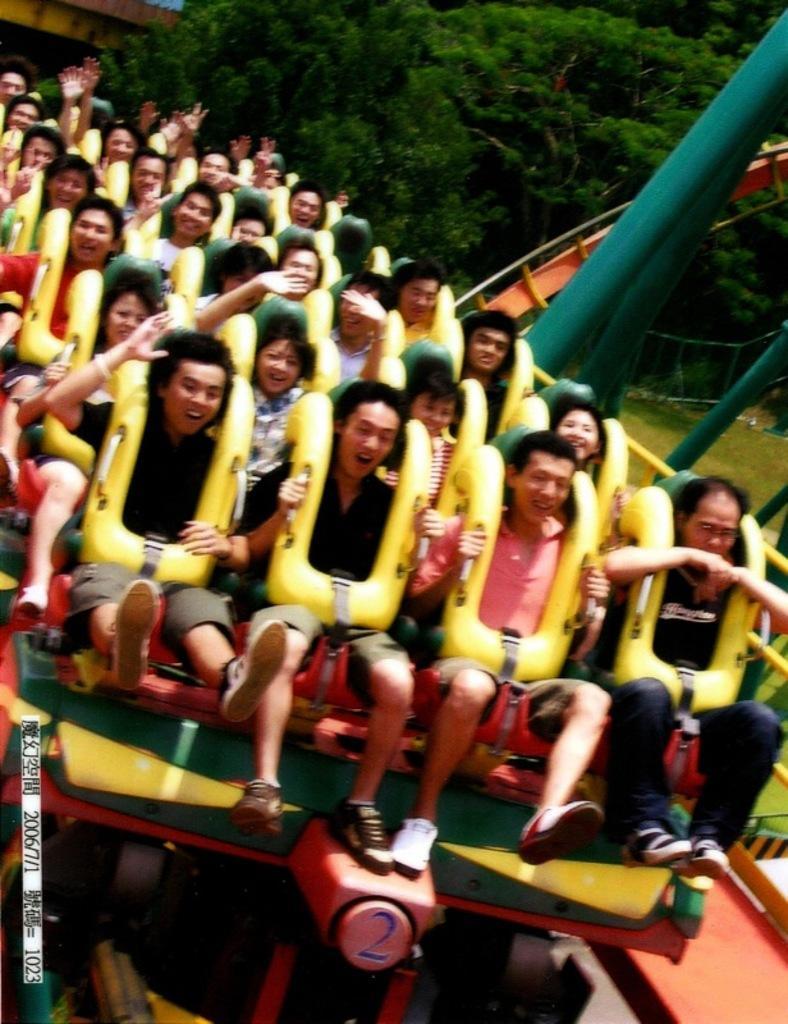In one or two sentences, can you explain what this image depicts? There are people sitting on ride. We can see rods and grass. In the background we can see trees. 